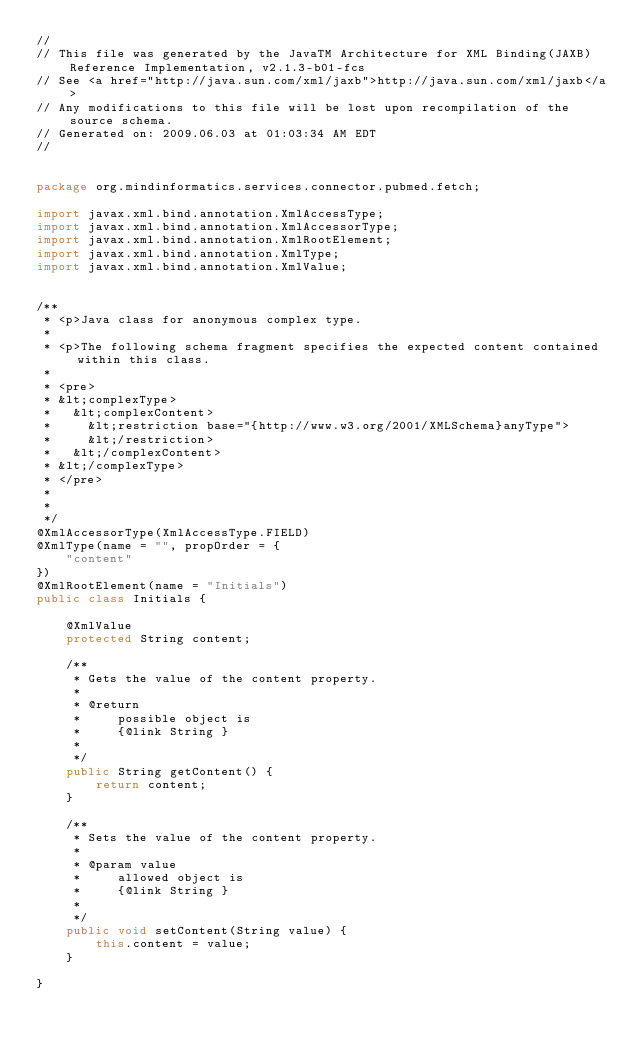<code> <loc_0><loc_0><loc_500><loc_500><_Java_>//
// This file was generated by the JavaTM Architecture for XML Binding(JAXB) Reference Implementation, v2.1.3-b01-fcs 
// See <a href="http://java.sun.com/xml/jaxb">http://java.sun.com/xml/jaxb</a> 
// Any modifications to this file will be lost upon recompilation of the source schema. 
// Generated on: 2009.06.03 at 01:03:34 AM EDT 
//


package org.mindinformatics.services.connector.pubmed.fetch;

import javax.xml.bind.annotation.XmlAccessType;
import javax.xml.bind.annotation.XmlAccessorType;
import javax.xml.bind.annotation.XmlRootElement;
import javax.xml.bind.annotation.XmlType;
import javax.xml.bind.annotation.XmlValue;


/**
 * <p>Java class for anonymous complex type.
 * 
 * <p>The following schema fragment specifies the expected content contained within this class.
 * 
 * <pre>
 * &lt;complexType>
 *   &lt;complexContent>
 *     &lt;restriction base="{http://www.w3.org/2001/XMLSchema}anyType">
 *     &lt;/restriction>
 *   &lt;/complexContent>
 * &lt;/complexType>
 * </pre>
 * 
 * 
 */
@XmlAccessorType(XmlAccessType.FIELD)
@XmlType(name = "", propOrder = {
    "content"
})
@XmlRootElement(name = "Initials")
public class Initials {

    @XmlValue
    protected String content;

    /**
     * Gets the value of the content property.
     * 
     * @return
     *     possible object is
     *     {@link String }
     *     
     */
    public String getContent() {
        return content;
    }

    /**
     * Sets the value of the content property.
     * 
     * @param value
     *     allowed object is
     *     {@link String }
     *     
     */
    public void setContent(String value) {
        this.content = value;
    }

}
</code> 